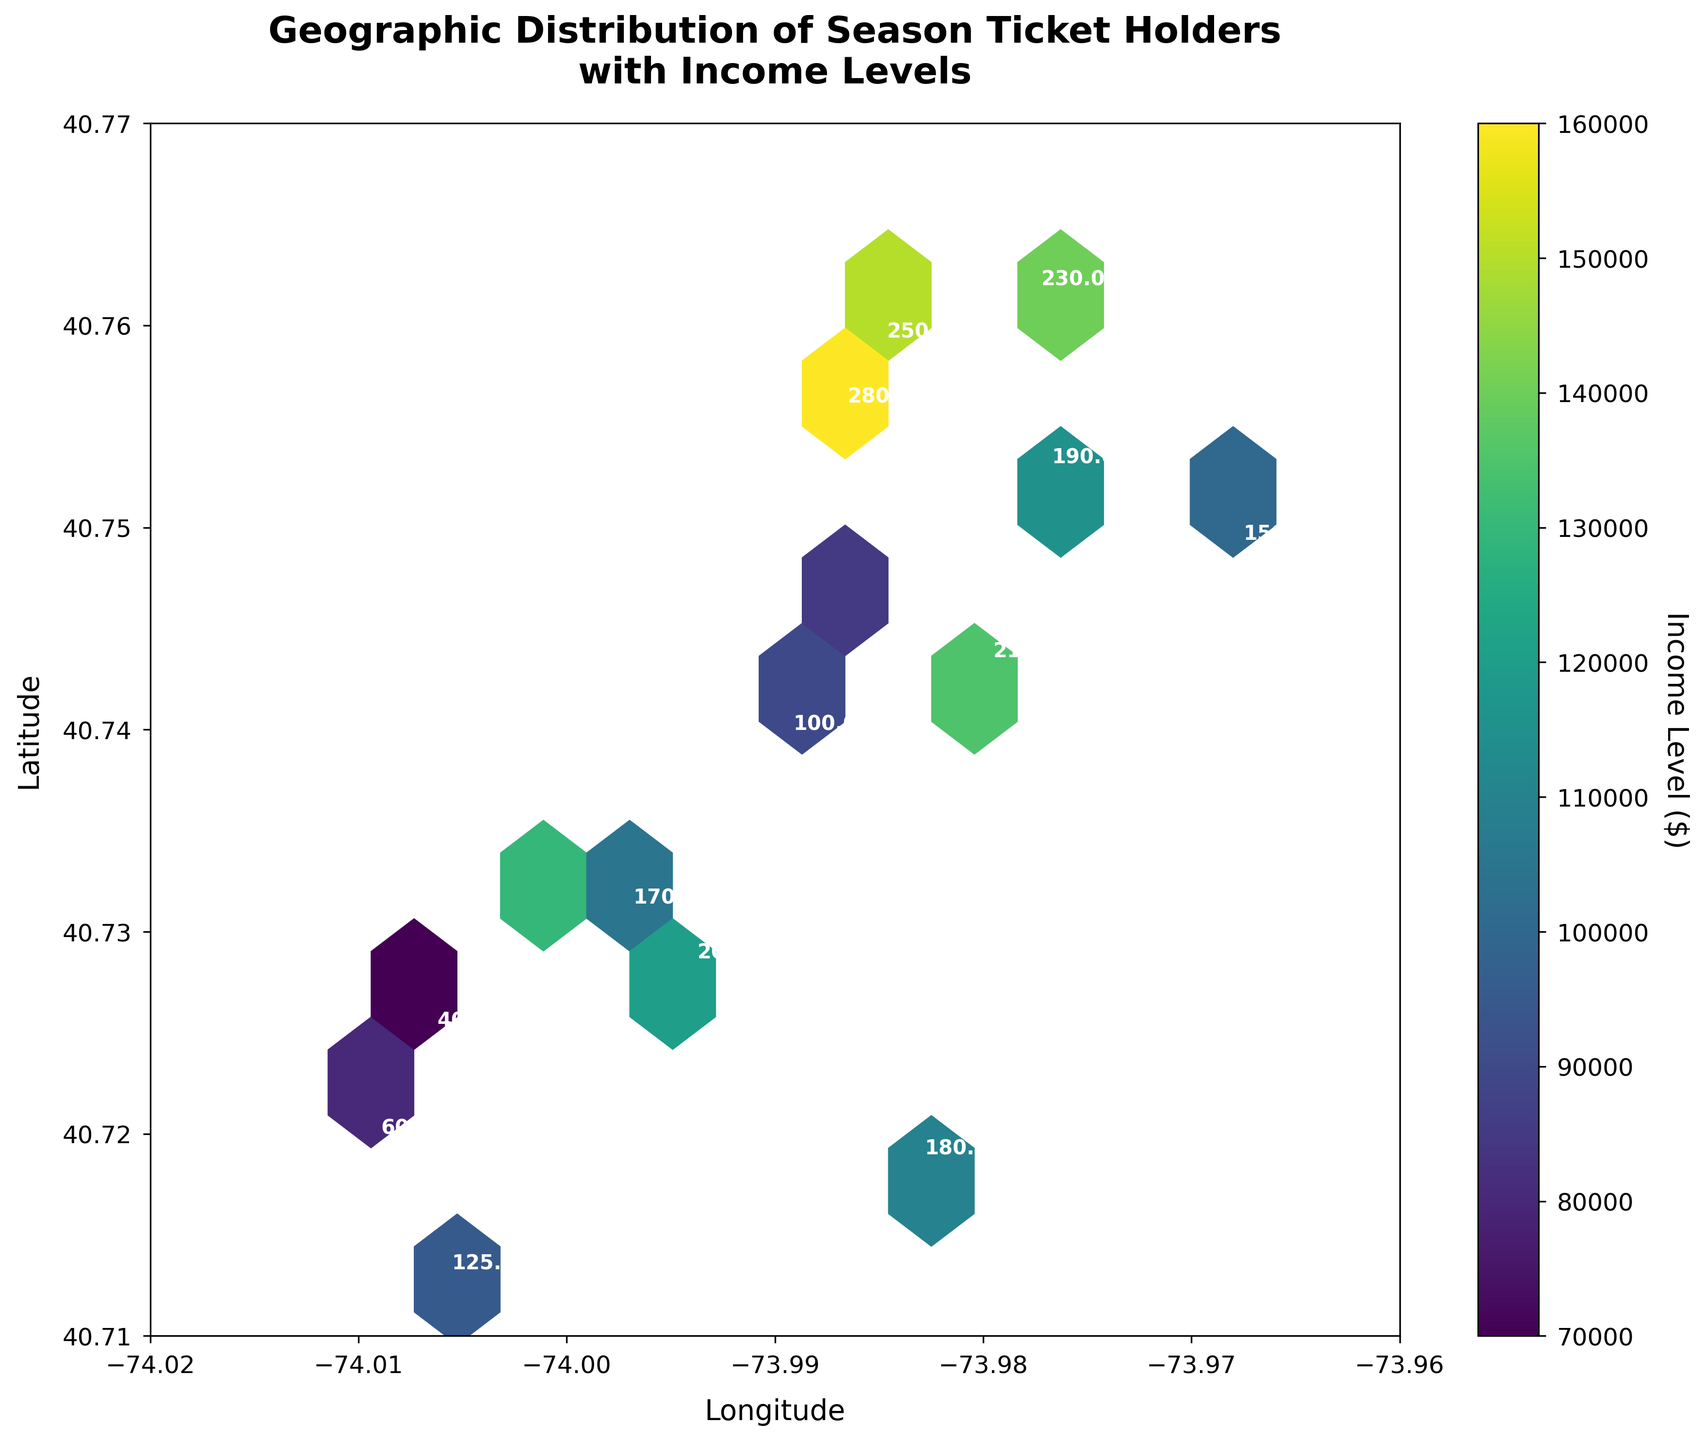What's the title of the plot? The title is written at the top of the plot. It reads 'Geographic Distribution of Season Ticket Holders with Income Levels'.
Answer: 'Geographic Distribution of Season Ticket Holders with Income Levels' What does the color bar represent? The color bar on the right side of the plot shows the scale in relation to 'Income Level ($)'.
Answer: 'Income Level ($)' What are the axes labels? The x-axis and y-axis labels are provided near the respective axes. The x-axis is labeled 'Longitude', and the y-axis is labeled 'Latitude'.
Answer: 'Longitude' and 'Latitude' Are there any season ticket holders with an income level below $75,000? By referring to the color bar scale and examining the color represented for each hexbin, there are no bins with colors corresponding to the income level below $75,000.
Answer: No Which area has the highest concentration of high-income season ticket holders? The area around the coordinates (40.7589, -73.9851) appears to have a dense and dark hexbin, indicating a high concentration of ticket holders with higher income levels.
Answer: Around coordinates (40.7589, -73.9851) What's the range of the longitude axis? Referring to the axis along the bottom of the plot, the longitude ranges from about -74.02 to -73.96.
Answer: -74.02 to -73.96 Compare the distribution of ticket holders' income levels between the areas with coordinates (40.7128, -74.0060) and (40.7484, -73.9857). Which has more high-income level ticket holders? By examining the hexbin colors coded to income levels, the area around (40.7128, -74.0060) shows lighter shades indicating lower income levels compared to the darker shades around (40.7484, -73.9857).
Answer: (40.7484, -73.9857) What's the median income level among all ticket holders as indicated in the hexbin plot? To determine the median, we look at the color distributions on the hexbin plot around which half the data would lie above and half below the central point represented by the color corresponding approximately to an income of $110,000 on the color scale.
Answer: Around $110,000 Is there a correlation between the season ticket holder density and income level? Observing the hexbin plot, the denser regions (more hexbins) appear to have darker shades which indicate higher income levels, suggesting a positive correlation.
Answer: Yes What is the color corresponding to the highest income level on the hexbin plot? Referring to the color bar on the right along with the plot, the highest income level is represented by the darkest shade of the 'viridis' color palette.
Answer: Darkest shade of 'viridis' 